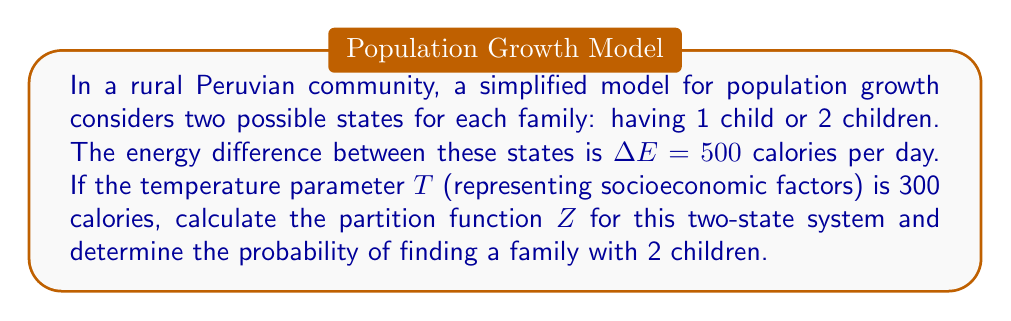Can you solve this math problem? 1. The partition function $Z$ for a two-state system is given by:
   $$Z = e^{-\beta E_1} + e^{-\beta E_2}$$
   where $\beta = \frac{1}{k_B T}$, $k_B$ is the Boltzmann constant (set to 1 for simplicity), and $E_1$ and $E_2$ are the energies of the two states.

2. Let's set $E_1 = 0$ (1 child) and $E_2 = \Delta E = 500$ calories (2 children).

3. Calculate $\beta$:
   $$\beta = \frac{1}{T} = \frac{1}{300} \approx 0.00333$$

4. Now, we can calculate the partition function:
   $$Z = e^{-\beta E_1} + e^{-\beta E_2} = e^0 + e^{-0.00333 \times 500} = 1 + e^{-1.665} \approx 1.189$$

5. To find the probability of a family having 2 children, we use:
   $$P(2\text{ children}) = \frac{e^{-\beta E_2}}{Z} = \frac{e^{-1.665}}{1.189} \approx 0.159$$

6. Convert to a percentage:
   $$0.159 \times 100\% = 15.9\%$$
Answer: $Z \approx 1.189$; $P(2\text{ children}) \approx 15.9\%$ 